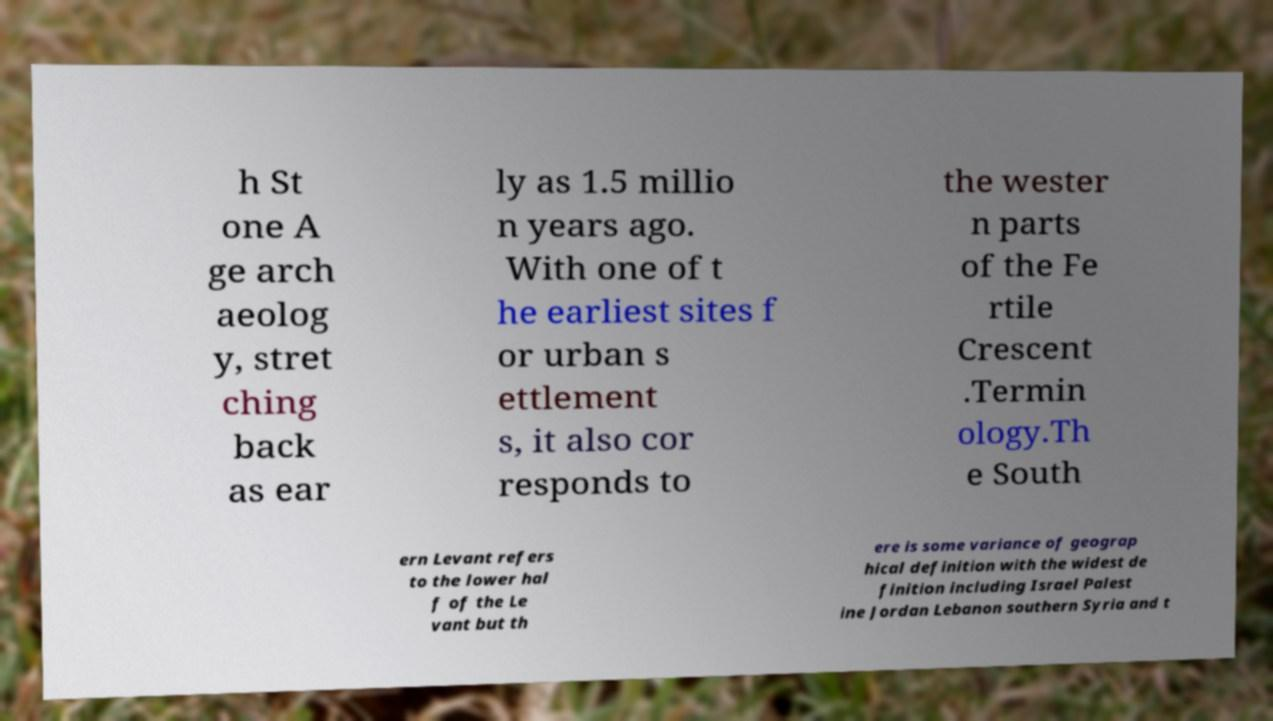Could you assist in decoding the text presented in this image and type it out clearly? h St one A ge arch aeolog y, stret ching back as ear ly as 1.5 millio n years ago. With one of t he earliest sites f or urban s ettlement s, it also cor responds to the wester n parts of the Fe rtile Crescent .Termin ology.Th e South ern Levant refers to the lower hal f of the Le vant but th ere is some variance of geograp hical definition with the widest de finition including Israel Palest ine Jordan Lebanon southern Syria and t 